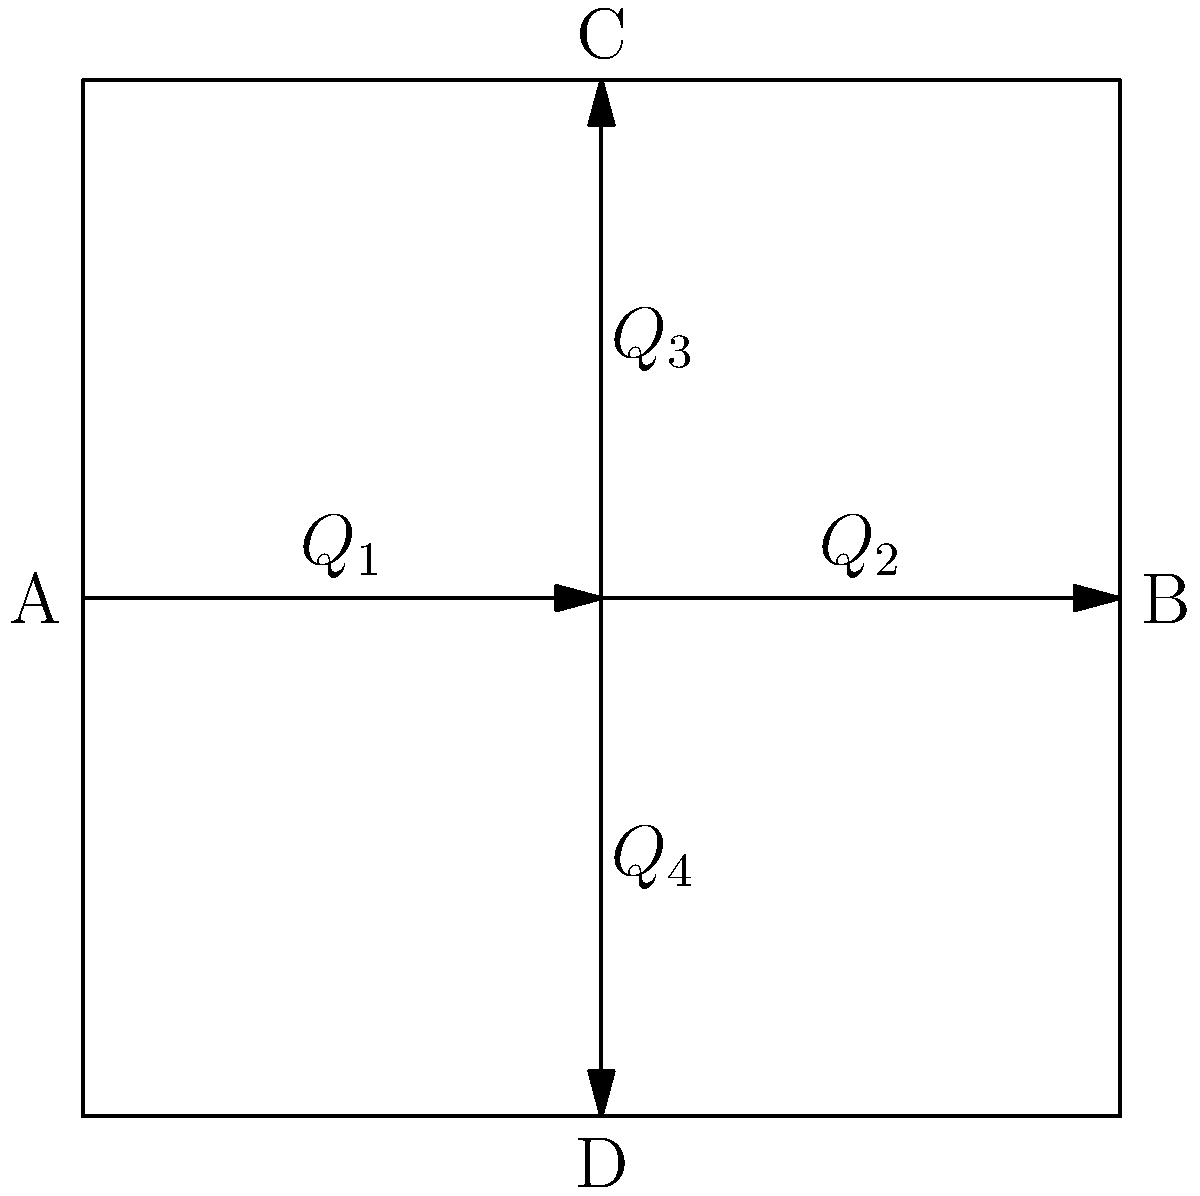In a pipe network auction, you're bidding on a system with four pipes connected at a central junction. The flow rates in pipes 1, 2, and 3 are known to be $Q_1 = 50$ L/s, $Q_2 = 30$ L/s, and $Q_3 = 15$ L/s, respectively. Assuming steady-state flow and conservation of mass, what is the flow rate $Q_4$ in the fourth pipe? To solve this problem, we'll use the principle of conservation of mass at the junction. In a steady-state flow, the sum of all inflows must equal the sum of all outflows.

Step 1: Identify inflows and outflows
- Inflow: $Q_1 = 50$ L/s
- Outflows: $Q_2 = 30$ L/s, $Q_3 = 15$ L/s, and unknown $Q_4$

Step 2: Apply conservation of mass
$$Q_1 = Q_2 + Q_3 + Q_4$$

Step 3: Substitute known values
$$50 = 30 + 15 + Q_4$$

Step 4: Solve for $Q_4$
$$Q_4 = 50 - 30 - 15 = 5$$

Therefore, the flow rate in the fourth pipe, $Q_4$, is 5 L/s.
Answer: 5 L/s 